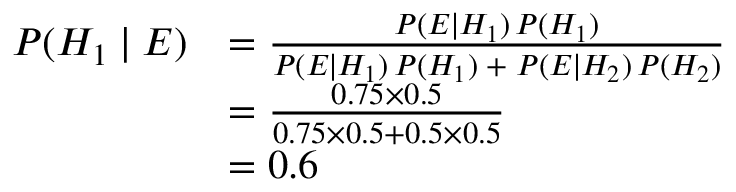Convert formula to latex. <formula><loc_0><loc_0><loc_500><loc_500>{ \begin{array} { r l } { P ( H _ { 1 } | E ) } & { = { \frac { P ( E | H _ { 1 } ) \, P ( H _ { 1 } ) } { P ( E | H _ { 1 } ) \, P ( H _ { 1 } ) \, + \, P ( E | H _ { 2 } ) \, P ( H _ { 2 } ) } } } \\ { \ } & { = { \frac { 0 . 7 5 \times 0 . 5 } { 0 . 7 5 \times 0 . 5 + 0 . 5 \times 0 . 5 } } } \\ { \ } & { = 0 . 6 } \end{array} }</formula> 